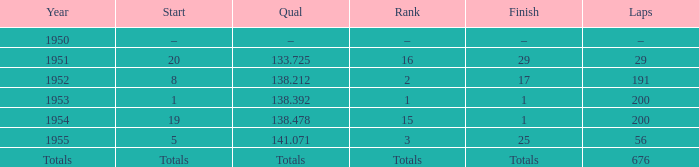When does the 676-lap race begin? Totals. 